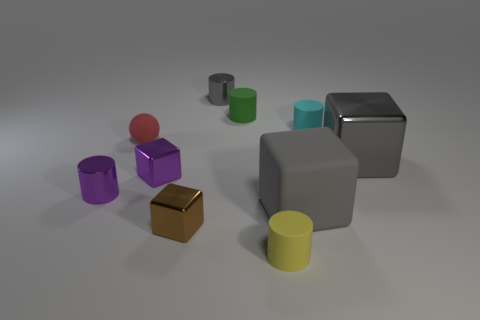There is a big rubber cube; does it have the same color as the tiny matte object that is behind the tiny cyan thing?
Ensure brevity in your answer.  No. Are there the same number of tiny gray metallic cylinders that are behind the small yellow rubber object and small yellow rubber cylinders?
Offer a very short reply. Yes. How many gray cubes are the same size as the green cylinder?
Offer a terse response. 0. What is the shape of the tiny shiny object that is the same color as the big rubber object?
Give a very brief answer. Cylinder. Are any brown metallic cubes visible?
Ensure brevity in your answer.  Yes. There is a gray shiny thing that is behind the red rubber object; is its shape the same as the brown shiny thing in front of the rubber ball?
Provide a succinct answer. No. How many tiny things are either brown metallic objects or metallic cylinders?
Your response must be concise. 3. There is a yellow thing that is the same material as the small sphere; what shape is it?
Make the answer very short. Cylinder. Is the brown thing the same shape as the cyan object?
Keep it short and to the point. No. The small rubber sphere is what color?
Provide a short and direct response. Red. 